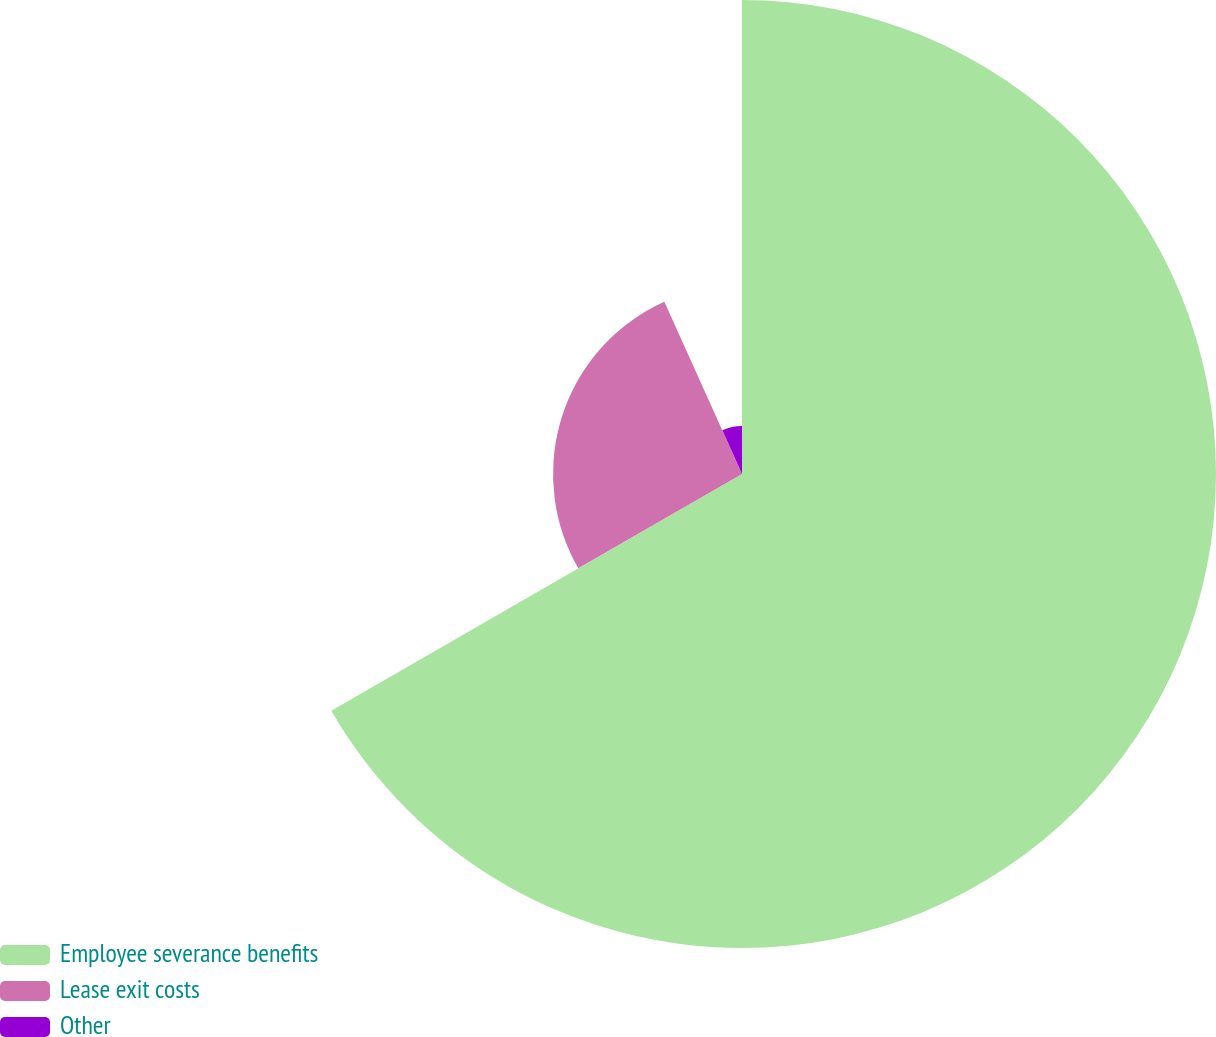Convert chart to OTSL. <chart><loc_0><loc_0><loc_500><loc_500><pie_chart><fcel>Employee severance benefits<fcel>Lease exit costs<fcel>Other<nl><fcel>66.68%<fcel>26.58%<fcel>6.74%<nl></chart> 